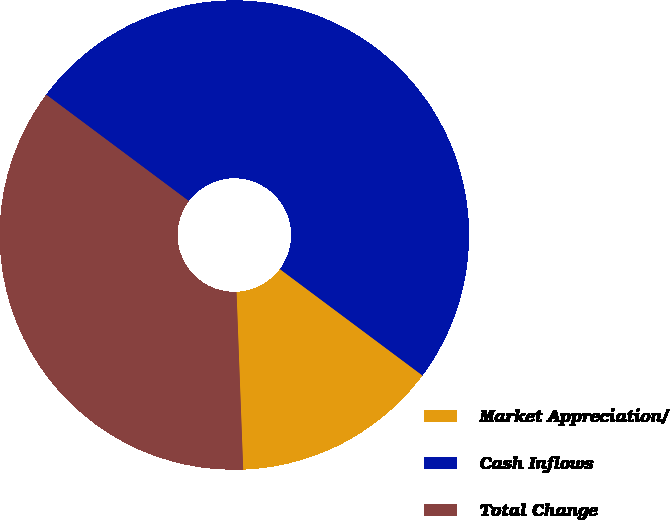Convert chart to OTSL. <chart><loc_0><loc_0><loc_500><loc_500><pie_chart><fcel>Market Appreciation/<fcel>Cash Inflows<fcel>Total Change<nl><fcel>14.2%<fcel>50.0%<fcel>35.8%<nl></chart> 